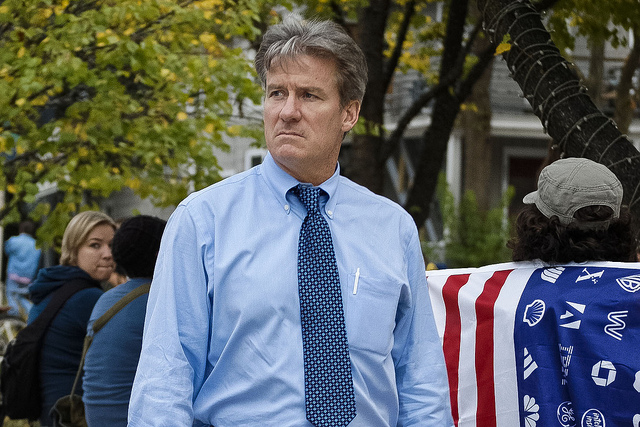Please transcribe the text information in this image. M X 